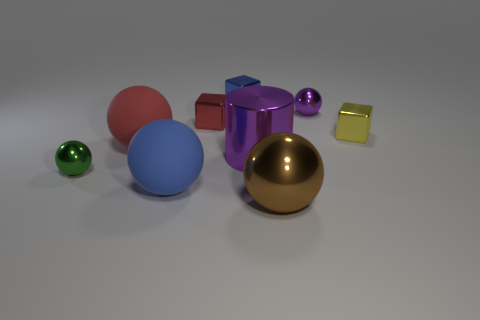There is a brown object that is the same shape as the green object; what is its material?
Keep it short and to the point. Metal. There is a cube that is on the left side of the blue thing behind the yellow metallic object; what size is it?
Keep it short and to the point. Small. Are any small yellow shiny objects visible?
Provide a short and direct response. Yes. There is a tiny object that is both in front of the red metal thing and on the right side of the small green thing; what material is it?
Make the answer very short. Metal. Is the number of brown metal objects that are on the left side of the blue shiny object greater than the number of metallic objects in front of the tiny yellow metallic cube?
Provide a succinct answer. No. Is there a red rubber object of the same size as the purple sphere?
Offer a terse response. No. There is a purple thing in front of the small cube to the right of the cube that is behind the purple metallic ball; what is its size?
Make the answer very short. Large. What is the color of the large shiny ball?
Offer a very short reply. Brown. Is the number of red things that are behind the yellow metallic object greater than the number of small cylinders?
Offer a very short reply. Yes. There is a tiny purple metal thing; what number of tiny metallic spheres are right of it?
Offer a very short reply. 0. 